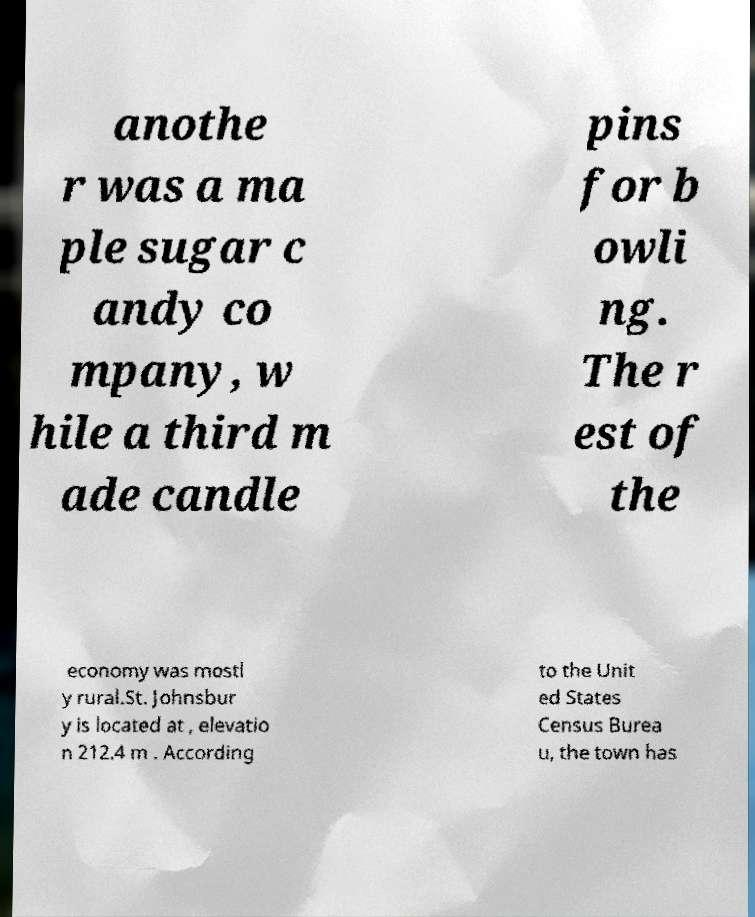Can you read and provide the text displayed in the image?This photo seems to have some interesting text. Can you extract and type it out for me? anothe r was a ma ple sugar c andy co mpany, w hile a third m ade candle pins for b owli ng. The r est of the economy was mostl y rural.St. Johnsbur y is located at , elevatio n 212.4 m . According to the Unit ed States Census Burea u, the town has 